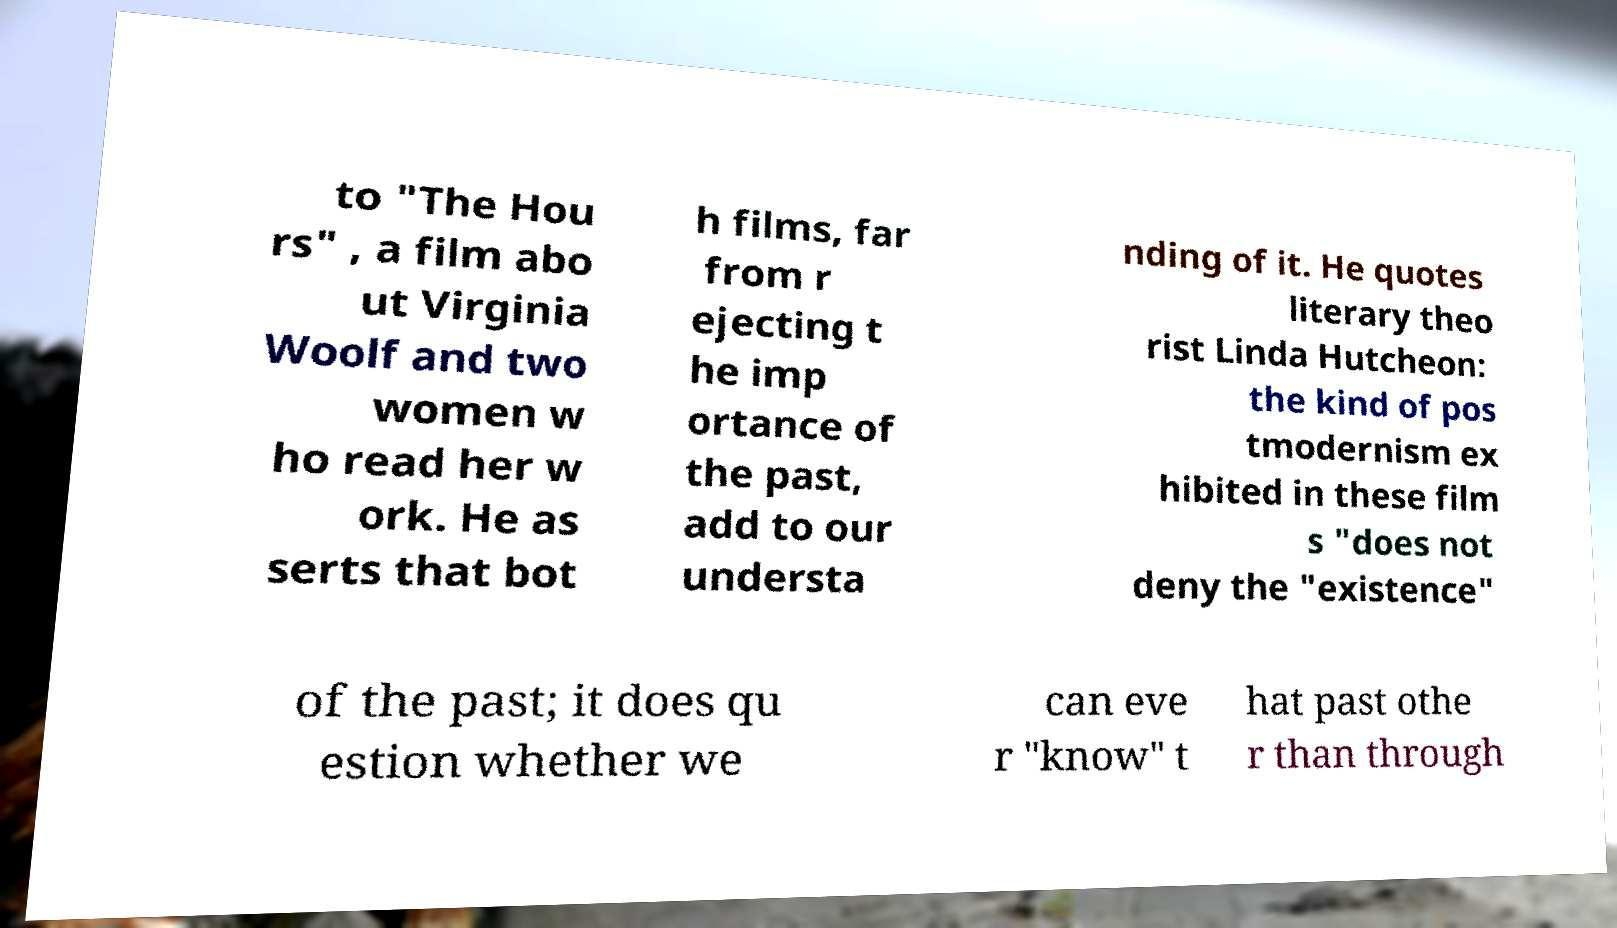For documentation purposes, I need the text within this image transcribed. Could you provide that? to "The Hou rs" , a film abo ut Virginia Woolf and two women w ho read her w ork. He as serts that bot h films, far from r ejecting t he imp ortance of the past, add to our understa nding of it. He quotes literary theo rist Linda Hutcheon: the kind of pos tmodernism ex hibited in these film s "does not deny the "existence" of the past; it does qu estion whether we can eve r "know" t hat past othe r than through 